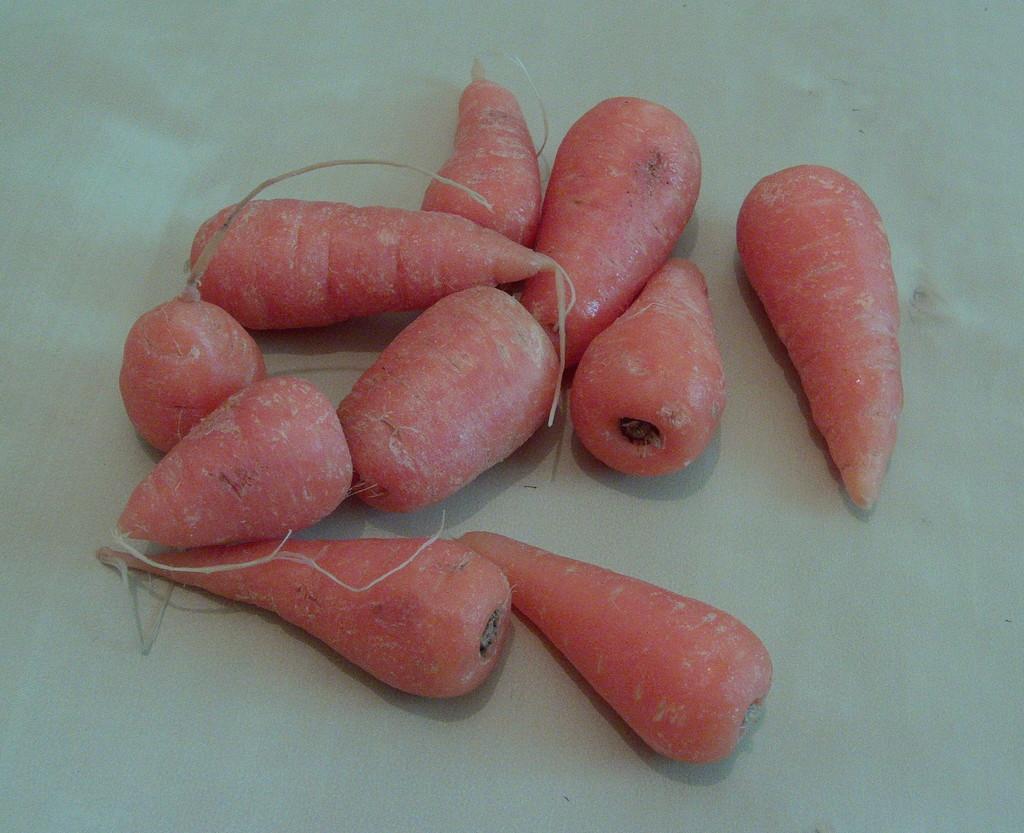Can you describe this image briefly? In the center of the image a carrots are present. 